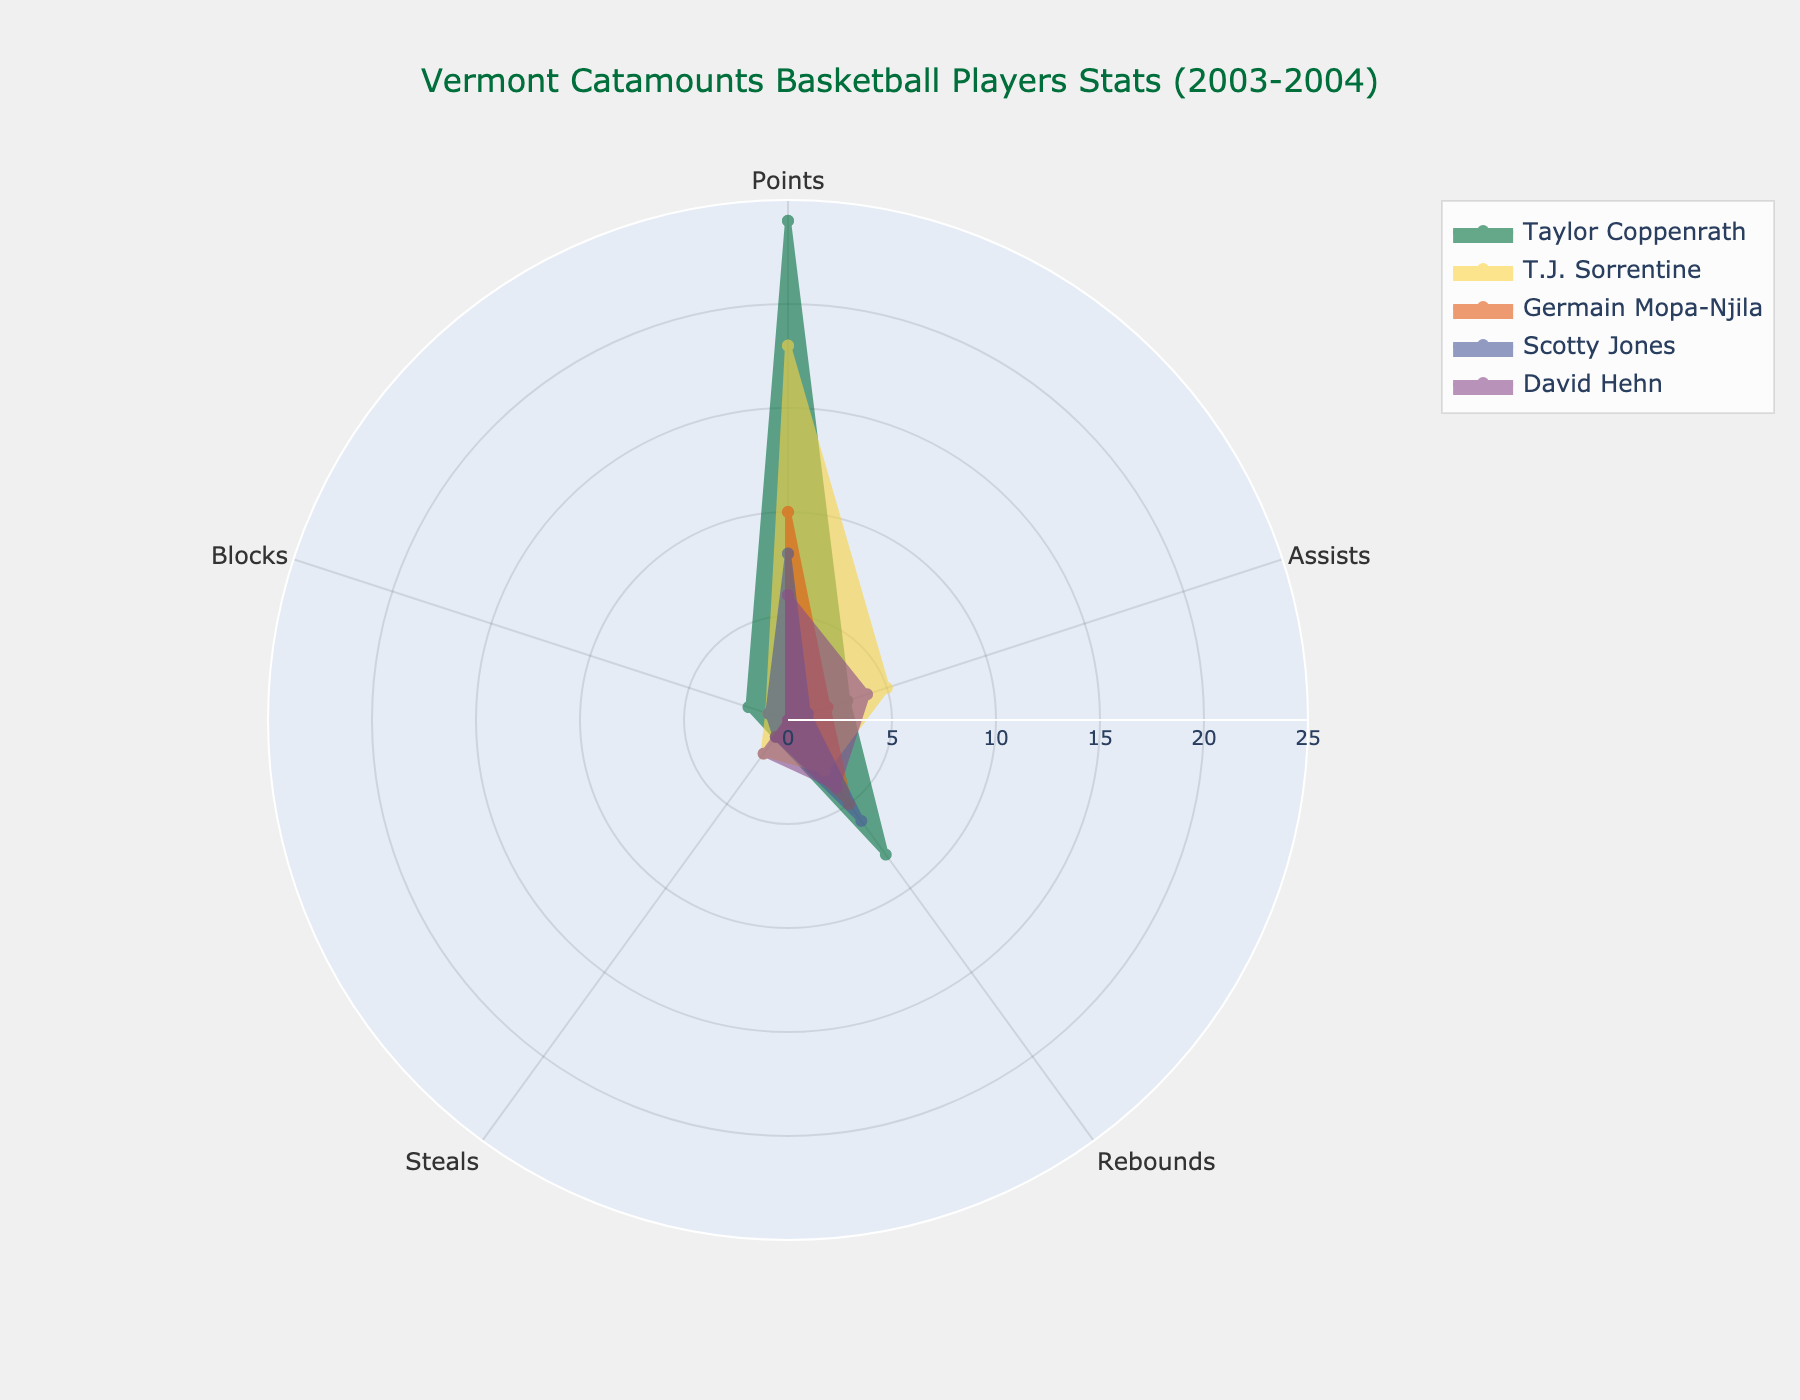What's the title of the chart? The title is located at the top of the chart and is usually in a larger and distinct font. Here, it reads "Vermont Catamounts Basketball Players Stats (2003-2004)".
Answer: Vermont Catamounts Basketball Players Stats (2003-2004) Which player has the highest total points? To determine this, locate the 'Points' section for each player on the radar chart and identify the highest value. Taylor Coppenrath has a value of 24 for points.
Answer: Taylor Coppenrath Compare the assists of Taylor Coppenrath and T.J. Sorrentine. Who has more? The radar chart will show the assists for both players in the 'Assists' section. Taylor Coppenrath has 3 assists, while T.J. Sorrentine has 5 assists.
Answer: T.J. Sorrentine How many players have a value greater than 1 in blocks? Examine the 'Blocks' section for each player. Taylor Coppenrath has 2, T.J. Sorrentine has 1, Scotty Jones has 1, and the others have 0. Only Taylor Coppenrath has more than 1 block.
Answer: 1 player What's the combined total of rebounds for Germain Mopa-Njila and Scotty Jones? Add the 'Rebounds' values for both players. Germain Mopa-Njila has 5 rebounds, and Scotty Jones has 6 rebounds. Summing them, we get 5 + 6 = 11.
Answer: 11 Which player has the highest rebounds, and what is the value? Check the 'Rebounds' values on the radar chart for each player. Taylor Coppenrath has 8 rebounds, which is the highest value.
Answer: Taylor Coppenrath (8) What is the average number of points scored by the players? Add all the 'Points' values and divide by the number of players. (24 + 18 + 10 + 8 + 6) / 5 = 66 / 5 = 13.2.
Answer: 13.2 Who has the lowest number of points, and how many points do they have? Locate the lowest value in the 'Points' section on the radar chart. David Hehn has the lowest points value, which is 6.
Answer: David Hehn (6) Compare the steals of David Hehn and Scotty Jones. Are they the same or different? Check the 'Steals' values for both players. Both David Hehn and Scotty Jones have 2 and 1 steals respectively, so they are different.
Answer: Different Which player has the least variability in their statistics across the categories? Identify the player whose values seem to be the most consistent and close to each other on the radar chart. Germain Mopa-Njila, whose values range from 0 to 10, appears to have the least variability.
Answer: Germain Mopa-Njila 